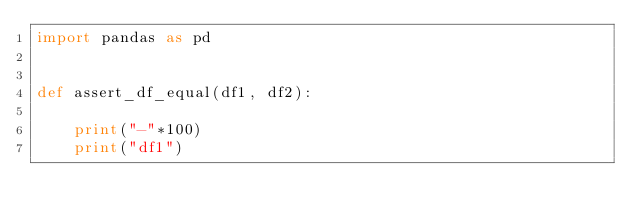Convert code to text. <code><loc_0><loc_0><loc_500><loc_500><_Python_>import pandas as pd


def assert_df_equal(df1, df2):

    print("-"*100)
    print("df1")</code> 